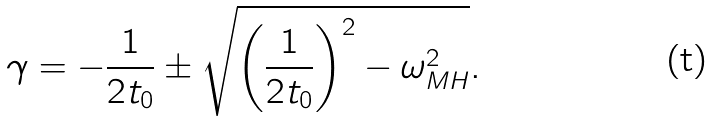Convert formula to latex. <formula><loc_0><loc_0><loc_500><loc_500>\gamma = - \frac { 1 } { 2 t _ { 0 } } \pm \sqrt { \left ( \frac { 1 } { 2 t _ { 0 } } \right ) ^ { 2 } - \omega _ { M H } ^ { 2 } } .</formula> 